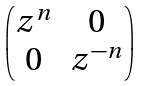<formula> <loc_0><loc_0><loc_500><loc_500>\begin{pmatrix} z ^ { n } & 0 \\ 0 & z ^ { - n } \end{pmatrix}</formula> 